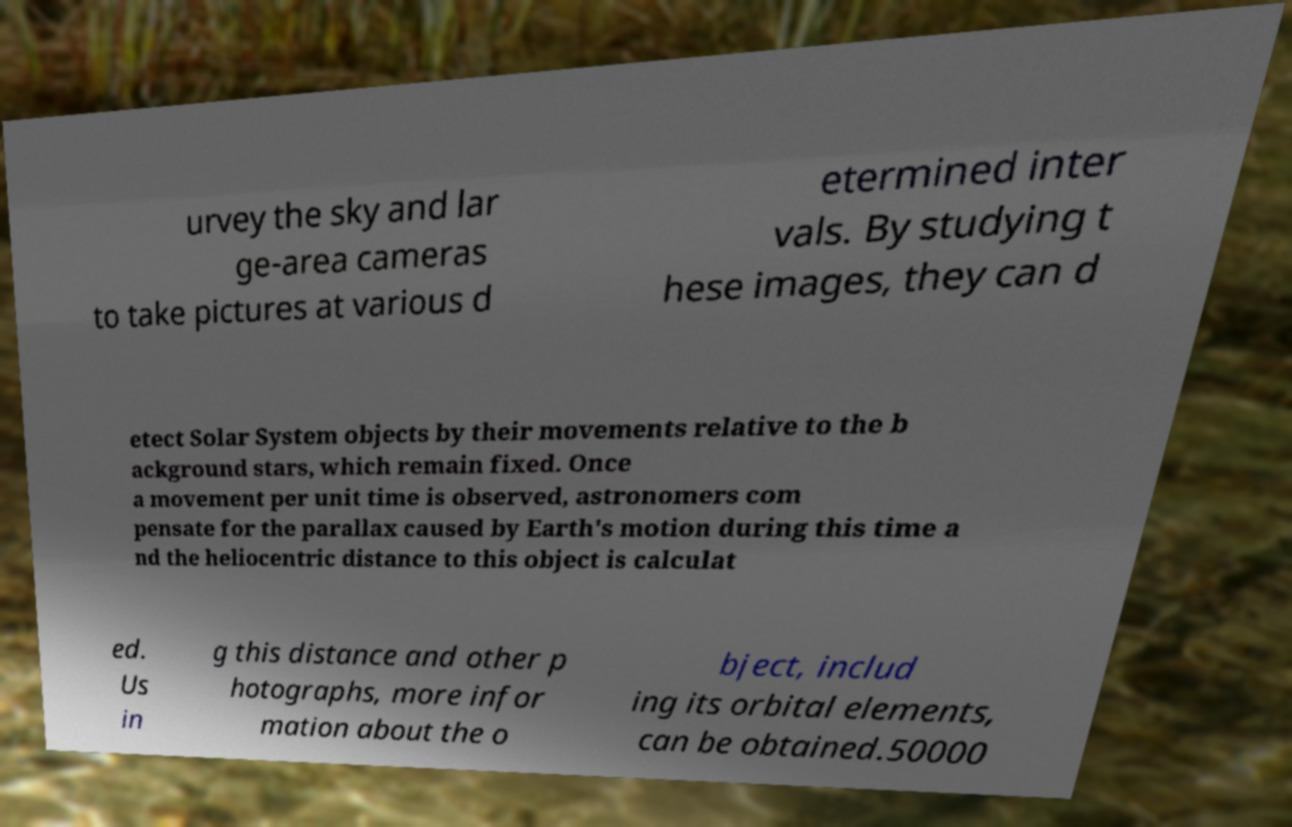Can you read and provide the text displayed in the image?This photo seems to have some interesting text. Can you extract and type it out for me? urvey the sky and lar ge-area cameras to take pictures at various d etermined inter vals. By studying t hese images, they can d etect Solar System objects by their movements relative to the b ackground stars, which remain fixed. Once a movement per unit time is observed, astronomers com pensate for the parallax caused by Earth's motion during this time a nd the heliocentric distance to this object is calculat ed. Us in g this distance and other p hotographs, more infor mation about the o bject, includ ing its orbital elements, can be obtained.50000 